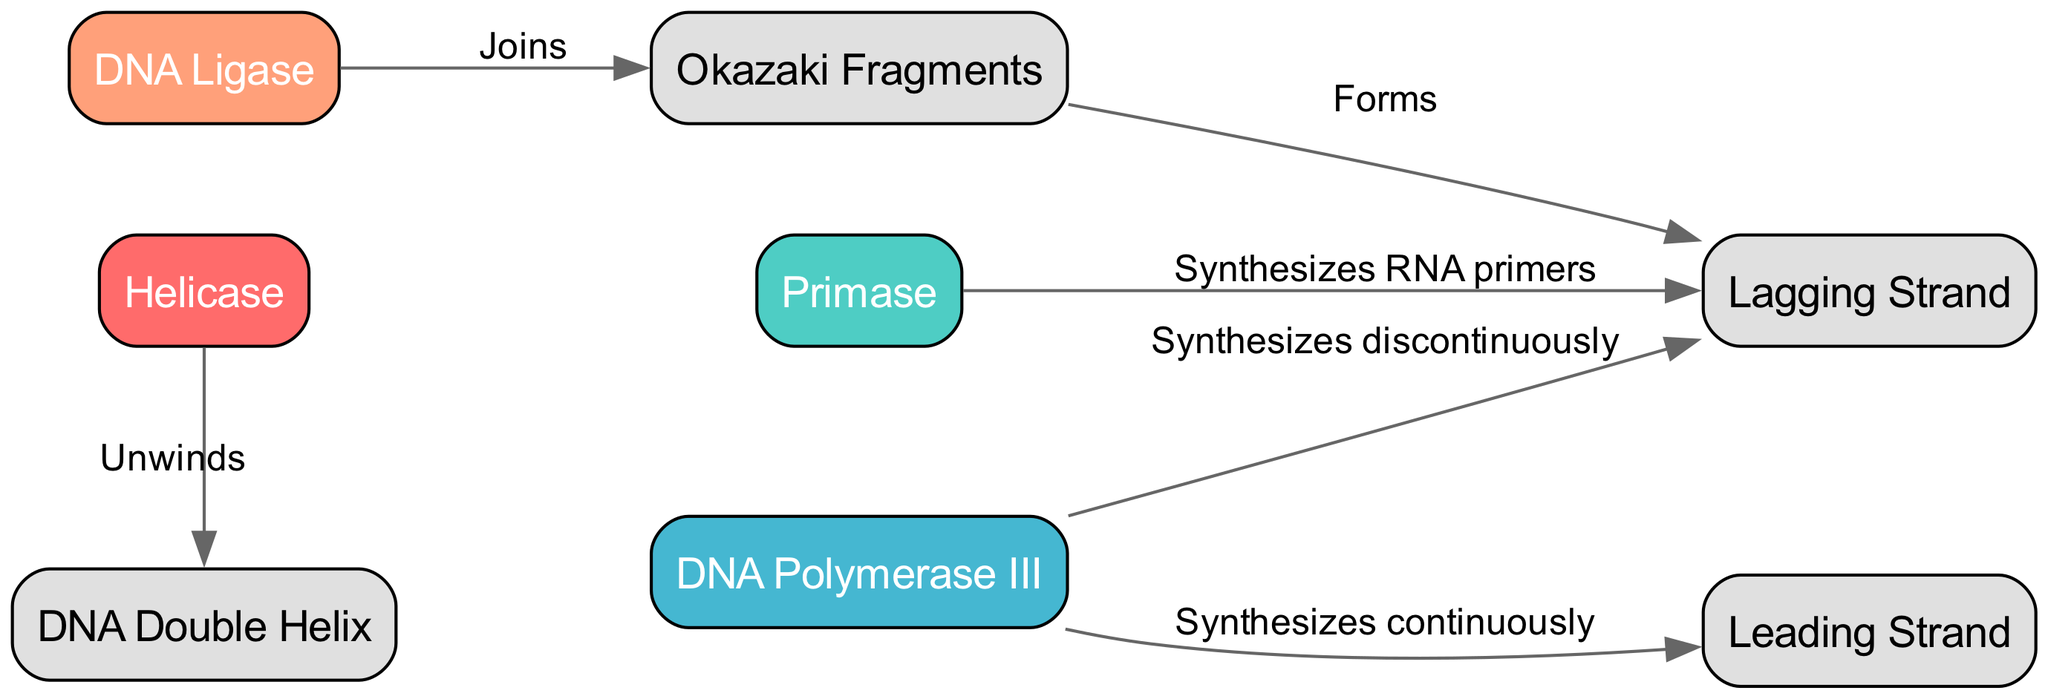What is the color of Helicase? Helicase is represented in the diagram with the color code #FF6B6B, which is a reddish color.
Answer: #FF6B6B How many enzymes are depicted in the diagram? The diagram displays four enzymes: Helicase, Primase, DNA Polymerase III, and DNA Ligase. Therefore, the total count of enzymes is four.
Answer: 4 What does DNA Polymerase III do in relation to the leading strand? According to the diagram, DNA Polymerase III synthesizes the leading strand continuously, indicating its direct role in this process.
Answer: Synthesizes continuously What is the relationship between Okazaki Fragments and the Lagging Strand? The diagram indicates that Okazaki Fragments form the Lagging Strand, establishing a direct connection between these two components in the process of DNA replication.
Answer: Forms Which enzyme joins Okazaki Fragments? The diagram specifies that DNA Ligase is responsible for joining the Okazaki Fragments during DNA replication.
Answer: DNA Ligase What does Primase synthesize for the Lagging Strand? The diagram illustrates that Primase synthesizes RNA primers specifically for the Lagging Strand, highlighting its vital role in the replication process.
Answer: RNA primers What is the primary role of Helicase in the process? Helicase is depicted in the diagram as unwinding the DNA double helix, indicating that its fundamental function is to separate the two strands of nucleotides.
Answer: Unwinds What is the purpose of the color coding in the diagram? The color coding helps to visually differentiate the various enzymes involved in the DNA replication process, making it easier to identify their roles at a glance.
Answer: Visual differentiation What is the flow direction of the diagram? The directed edges in the diagram indicate that the flow of DNA replication processes from Helicase to Primase and DNA Polymerase III, leading towards the creation of the Lagging and Leading Strands.
Answer: Left to right 